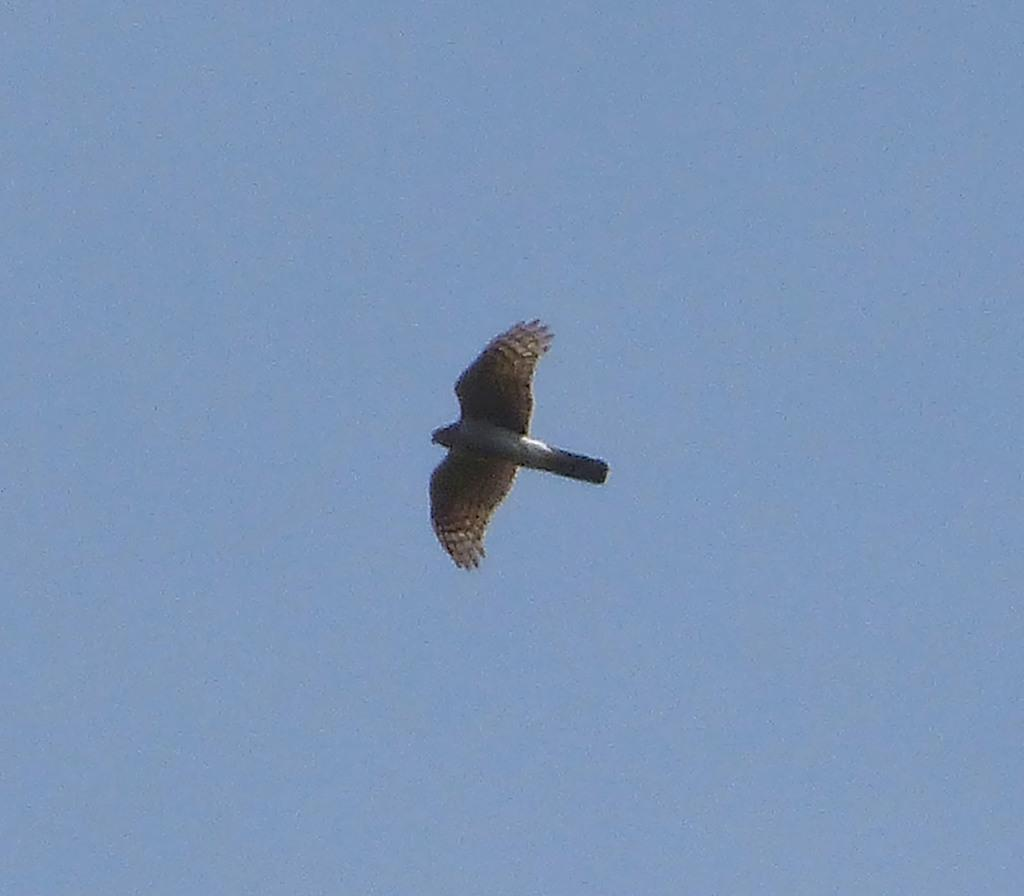What type of animal can be seen in the image? There is a bird in the image. What part of the natural environment is visible in the image? The sky is visible in the image. What type of polish is the bird using on its pocket in the image? There is no indication in the image that the bird is using any polish or has a pocket. 